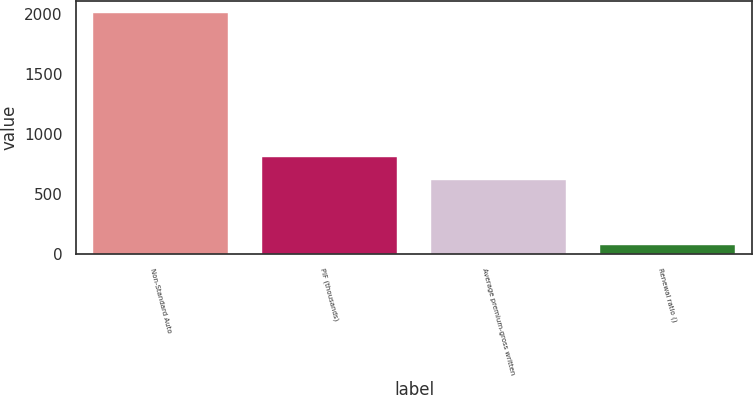<chart> <loc_0><loc_0><loc_500><loc_500><bar_chart><fcel>Non-Standard Auto<fcel>PIF (thousands)<fcel>Average premium-gross written<fcel>Renewal ratio ()<nl><fcel>2009<fcel>809.65<fcel>616<fcel>72.5<nl></chart> 